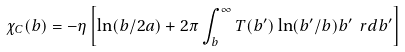Convert formula to latex. <formula><loc_0><loc_0><loc_500><loc_500>\chi _ { C } ( b ) = - \eta \left [ \ln ( b / 2 a ) + 2 \pi \int _ { b } ^ { \infty } T ( b ^ { \prime } ) \ln ( b ^ { \prime } / b ) b ^ { \prime } \ r d b ^ { \prime } \right ]</formula> 